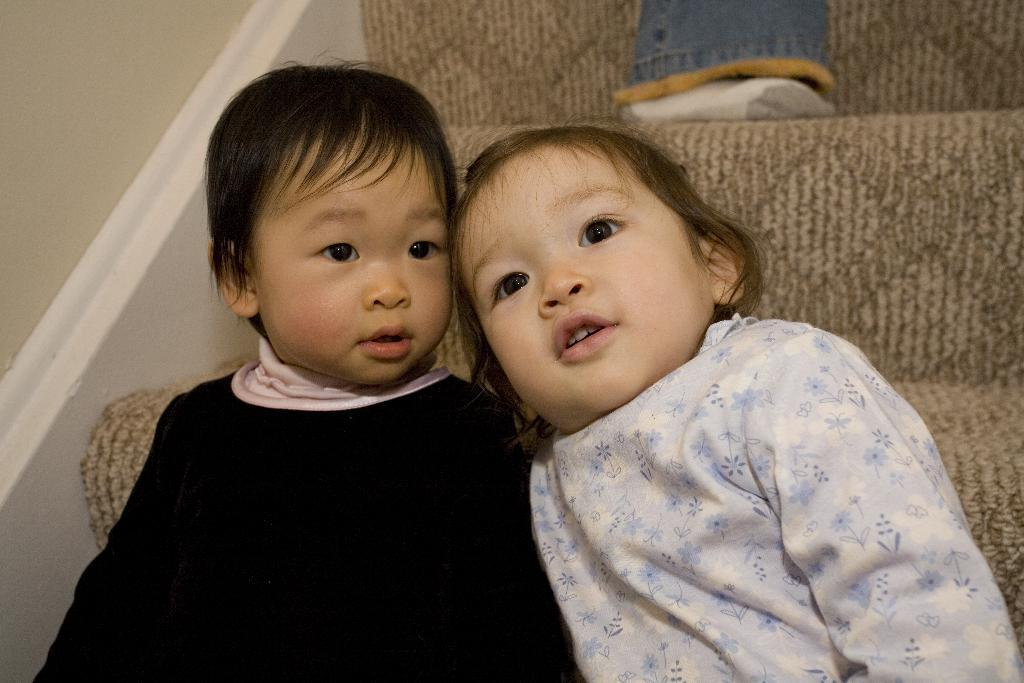How many kids are present in the image? There are two kids sitting in the image. What can be seen in the background of the image? There are stairs and a wall in the background of the image. What type of apparel are the cows wearing in the image? There are no cows present in the image, so it is not possible to determine what type of apparel they might be wearing. 